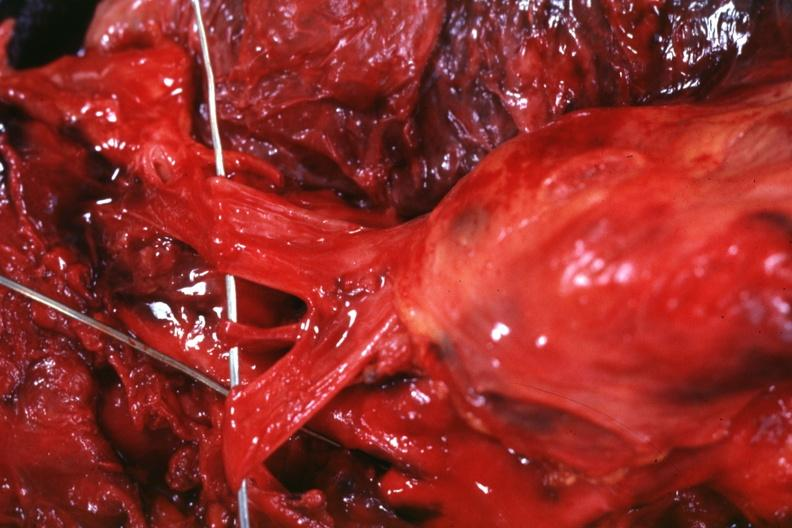what is present?
Answer the question using a single word or phrase. Hematologic 